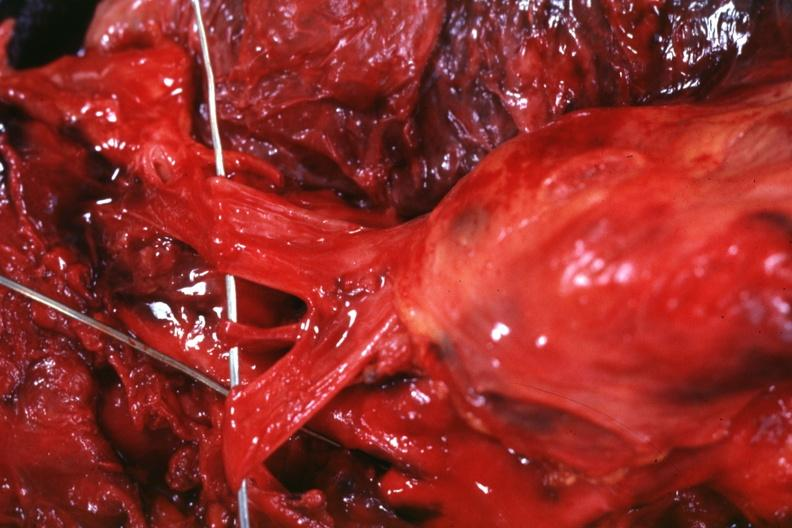what is present?
Answer the question using a single word or phrase. Hematologic 